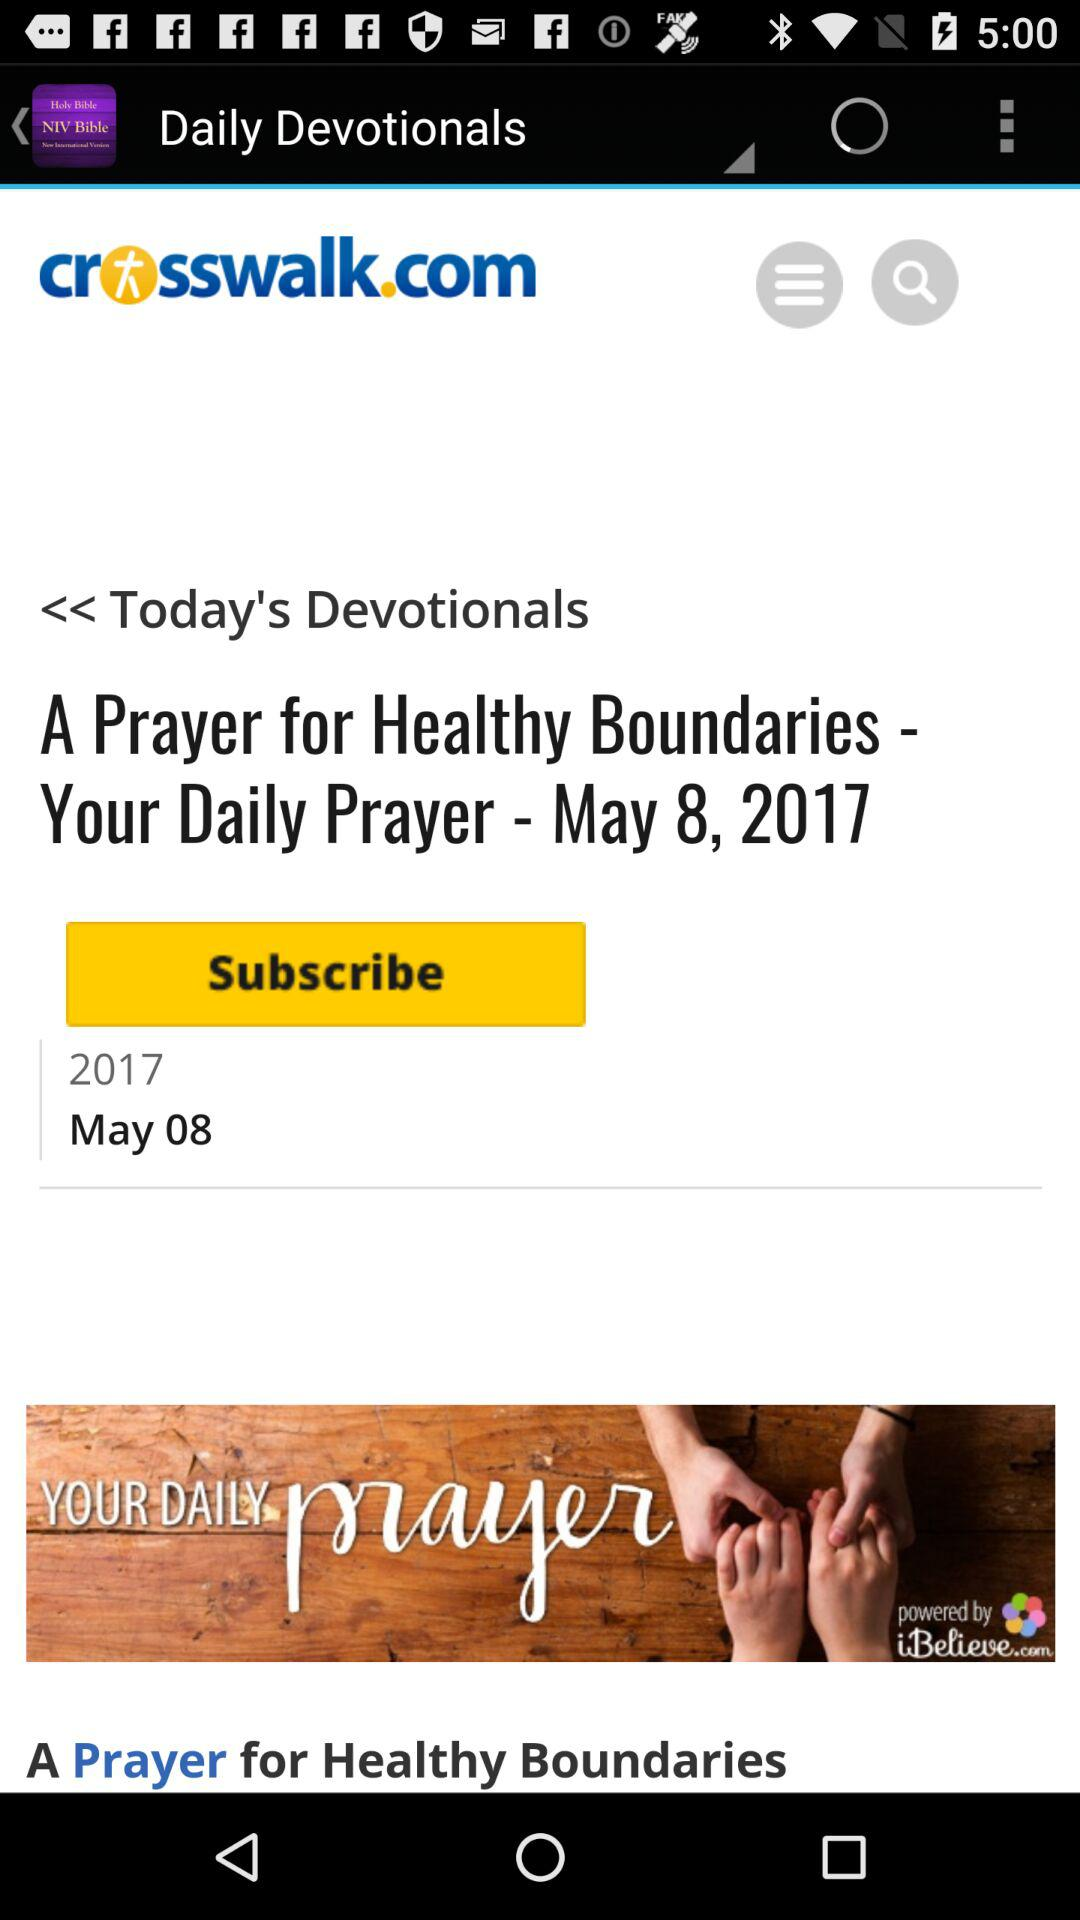What is the name of the article headline? The article headline is "A Prayer for Healthy Boundaries Your Daily Prayer". 